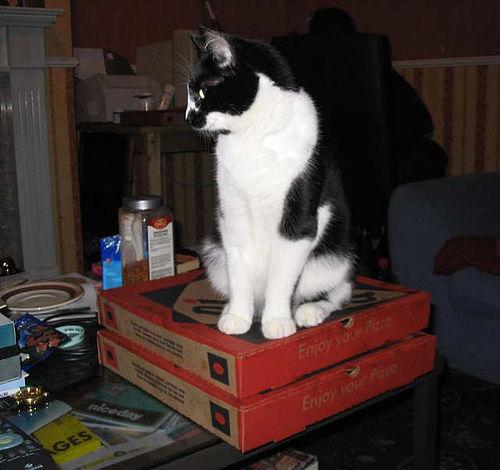What colors make up the cat's coat?
Concise answer only. Black and white. Is this cat trying to catch a mouse?
Be succinct. No. What is the slogan on the pizza box?
Quick response, please. Enjoy your pizza. Whose pets are these?
Write a very short answer. Owner. 